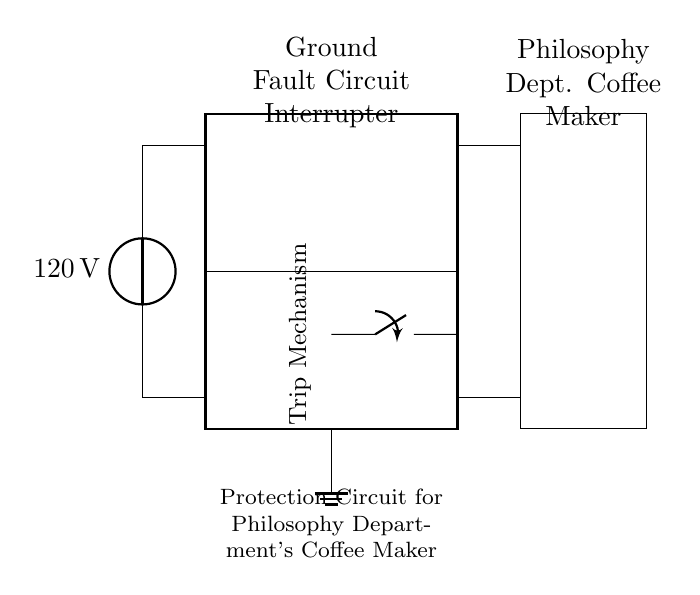What is the voltage of this circuit? The voltage is 120 volts, which is indicated by the voltage source connected at the beginning of the circuit.
Answer: 120 volts What is the role of the rectangle labeled "Ground Fault Circuit Interrupter"? The rectangle houses the Ground Fault Circuit Interrupter, which is responsible for detecting ground faults and disconnecting the circuit to protect devices like the coffee maker.
Answer: Protection device What component is connected to the sensing coil? The trip mechanism is directly connected to the sensing coil, which monitors current differences to identify faults.
Answer: Trip mechanism How does the GFCI respond to a fault condition? The GFCI detects differences between incoming and outgoing current; if it finds a discrepancy, it trips the mechanism and disconnects the circuit, preventing electric shock or damage.
Answer: Interrupts current flow What type of coffee maker is in the circuit? The component labeled is a coffee maker, specifically mentioned as belonging to the Philosophy Department.
Answer: Philosophy Dept. Coffee Maker What is the ground connection in the circuit? The ground connection is represented by a ground symbol and is essential for safety, ensuring any stray current is redirected safely into the earth.
Answer: Ground connection 